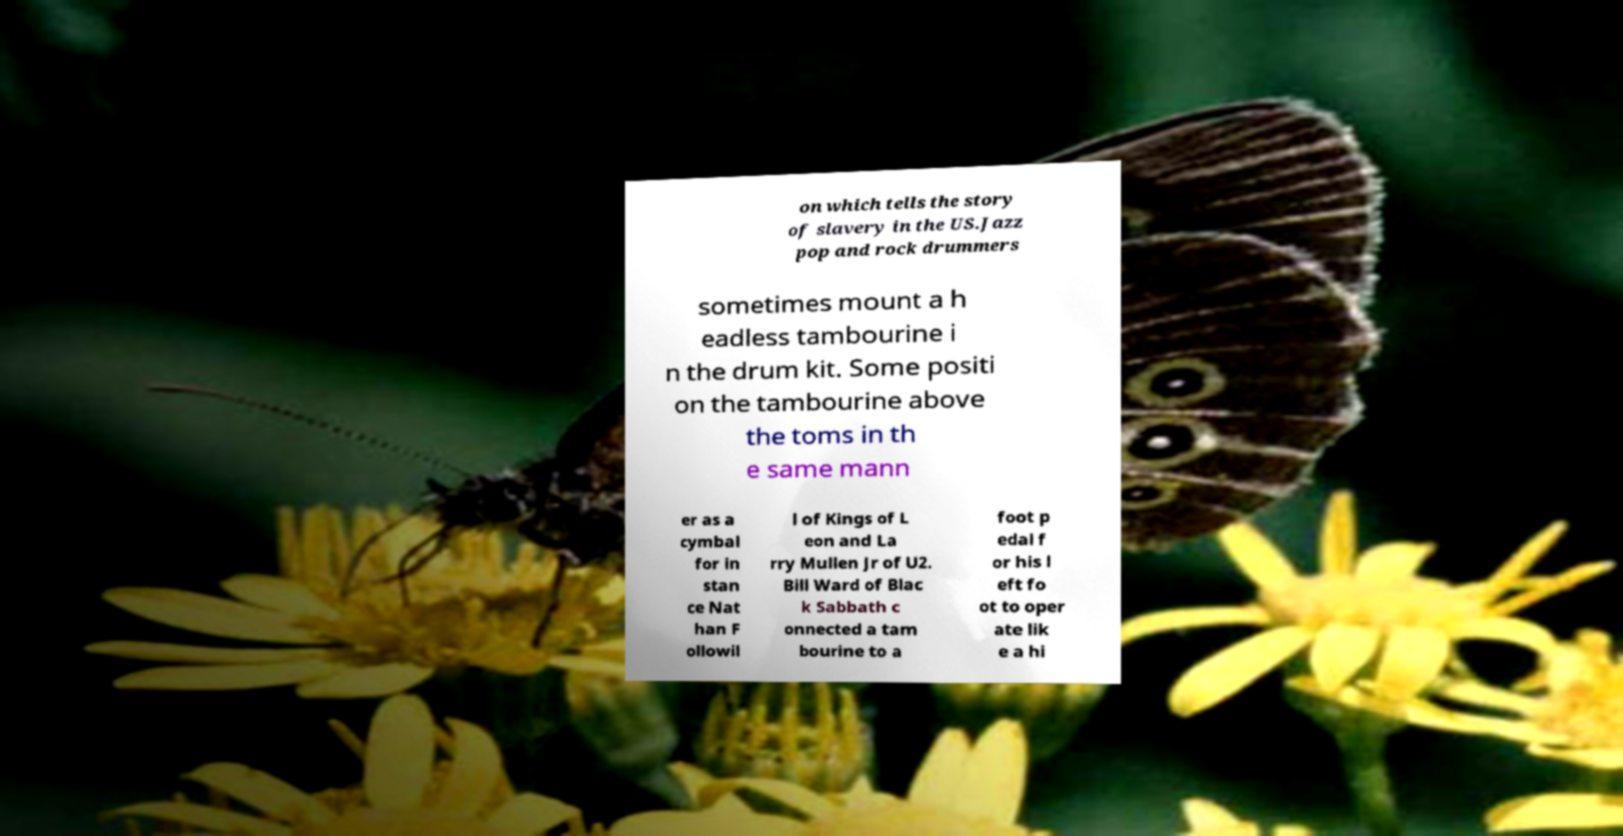What messages or text are displayed in this image? I need them in a readable, typed format. on which tells the story of slavery in the US.Jazz pop and rock drummers sometimes mount a h eadless tambourine i n the drum kit. Some positi on the tambourine above the toms in th e same mann er as a cymbal for in stan ce Nat han F ollowil l of Kings of L eon and La rry Mullen Jr of U2. Bill Ward of Blac k Sabbath c onnected a tam bourine to a foot p edal f or his l eft fo ot to oper ate lik e a hi 